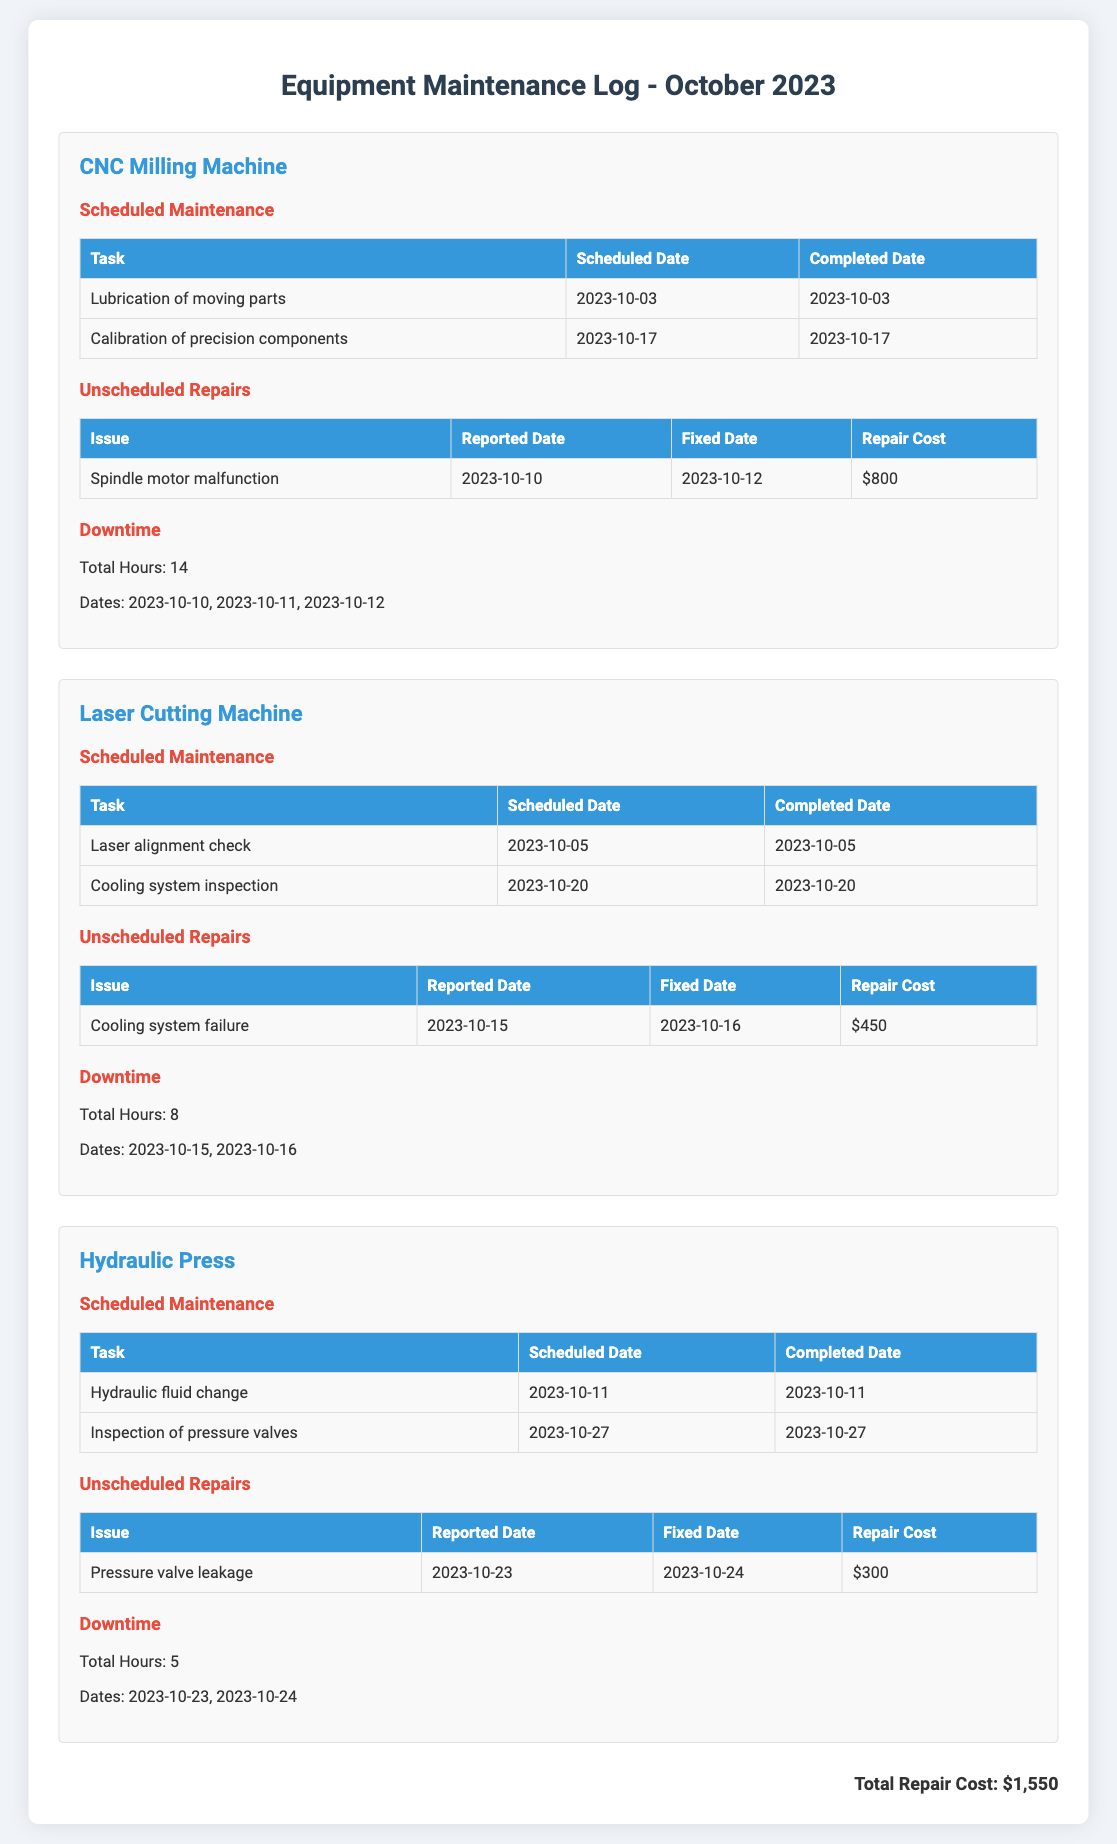What was the scheduled date for lubrication of moving parts? The scheduled date for lubrication of moving parts is mentioned in the maintenance section for the CNC Milling Machine, which is 2023-10-03.
Answer: 2023-10-03 How much was the repair cost for the spindle motor malfunction? The repair cost for the spindle motor malfunction is detailed in the repairs section for the CNC Milling Machine as $800.
Answer: $800 What is the total downtime for the Laser Cutting Machine? The total downtime for the Laser Cutting Machine is stated in the downtime section as 8 hours.
Answer: 8 On which date was the hydraulic fluid changed for the Hydraulic Press? The hydraulic fluid change scheduled is indicated as completed on 2023-10-11 in the maintenance section.
Answer: 2023-10-11 How many unscheduled repairs were reported for the CNC Milling Machine? There is one unscheduled repair reported for the CNC Milling Machine, which is the spindle motor malfunction.
Answer: One What is the total repair cost across all machines? The total repair cost is summarized at the bottom of the document and is calculated as $800 + $450 + $300 = $1550.
Answer: $1550 Which machine had scheduled maintenance for pressure valves on 2023-10-27? The maintenance task for pressure valves on 2023-10-27 is listed under the Hydraulic Press.
Answer: Hydraulic Press Which issue caused the Laser Cutting Machine to be unscheduled for repairs? The issue that led to unscheduled repairs for the Laser Cutting Machine is the cooling system failure.
Answer: Cooling system failure What was the completed date for cooling system inspection? The completed date for the cooling system inspection is listed in the maintenance section for the Laser Cutting Machine as 2023-10-20.
Answer: 2023-10-20 